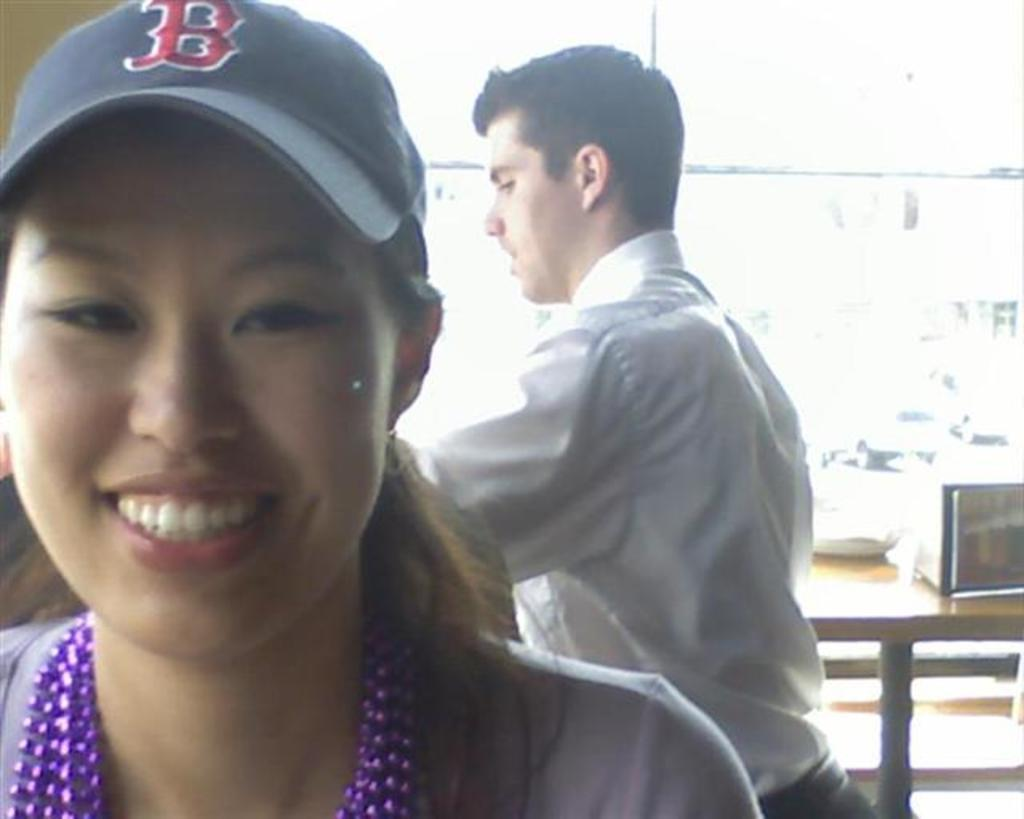How many people are in the image? There are people in the image, but the exact number is not specified. Can you describe the clothing of one of the people? One of the people is wearing a cap. What can be seen in the background of the image? There are objects on a table in the background of the image. Can you tell me how many waves are visible in the ocean in the image? There is no ocean present in the image, so it is not possible to determine the number of waves. 